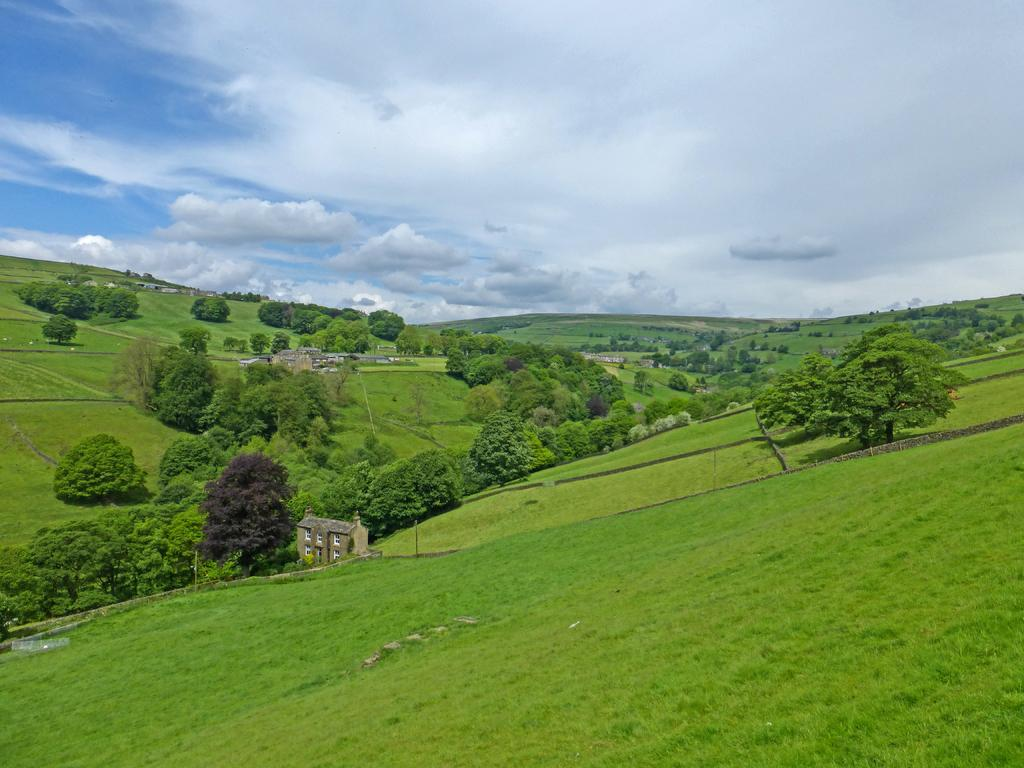What type of vegetation can be seen in the image? There are trees in the image. What type of structures are present in the image? There are buildings in the image. What is covering the ground at the bottom of the image? There is grass on the surface at the bottom of the image. What is visible in the background of the image? There is sky visible in the background of the image. Can you see an owl flying in the sky in the image? There is no owl present in the image; only trees, buildings, grass, and sky are visible. Is there any liquid visible in the image? There is no liquid visible in the image. 